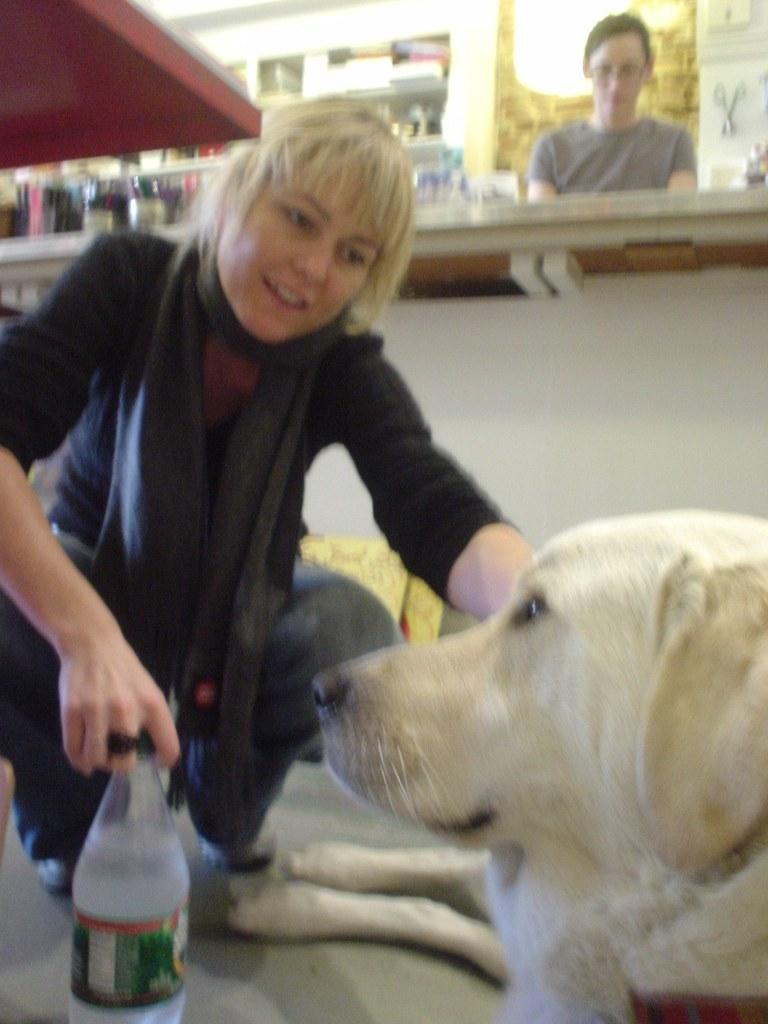What is the woman holding in the image? The woman is holding a bottle in the image. What is the woman doing with the dog? The woman is pampering a dog. Can you describe the second woman in the image? The second woman is standing in the image and is near a bench. What type of record is the woman playing for the dog in the image? There is no record player or record visible in the image, and the woman is not playing any music for the dog. 